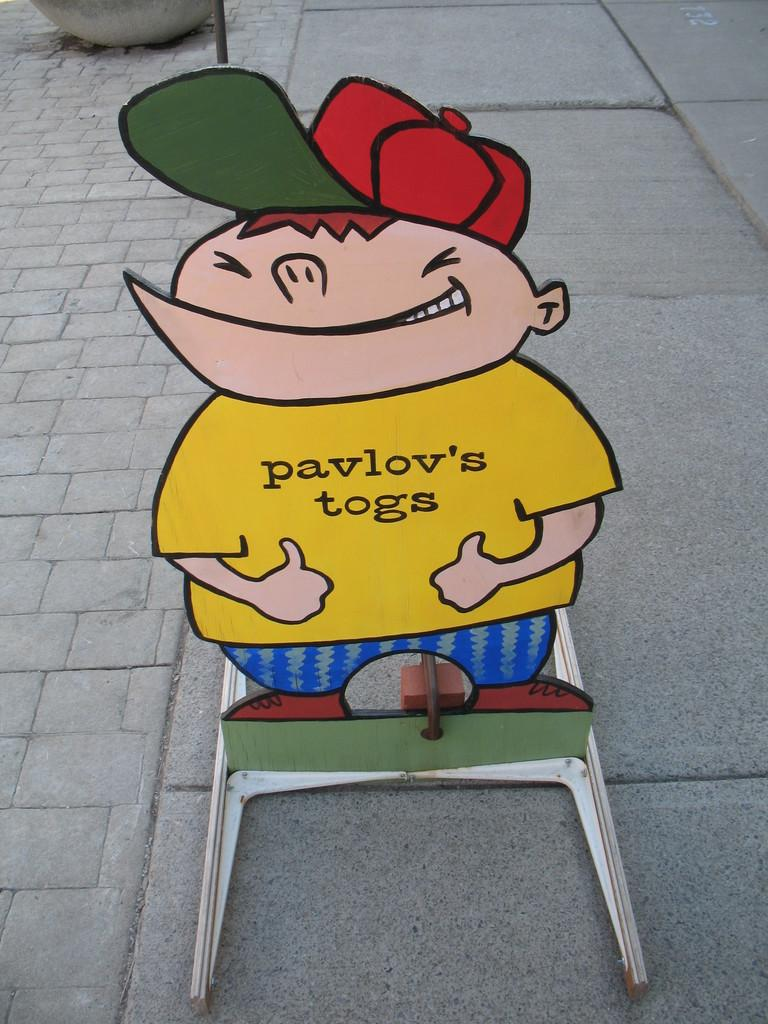What is the main subject in the center of the image? There is a cartoon stand in the center of the image. What can be seen in the background of the image? There is a pot and a road in the background of the image. What type of pen is being used to draw the cartoons in the image? There is no pen visible in the image, and it is not clear if the cartoons are being drawn by hand or created digitally. 